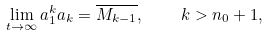<formula> <loc_0><loc_0><loc_500><loc_500>\lim _ { t \rightarrow \infty } a _ { 1 } ^ { k } a _ { k } = \overline { M _ { k - 1 } } , \quad k > n _ { 0 } + 1 ,</formula> 